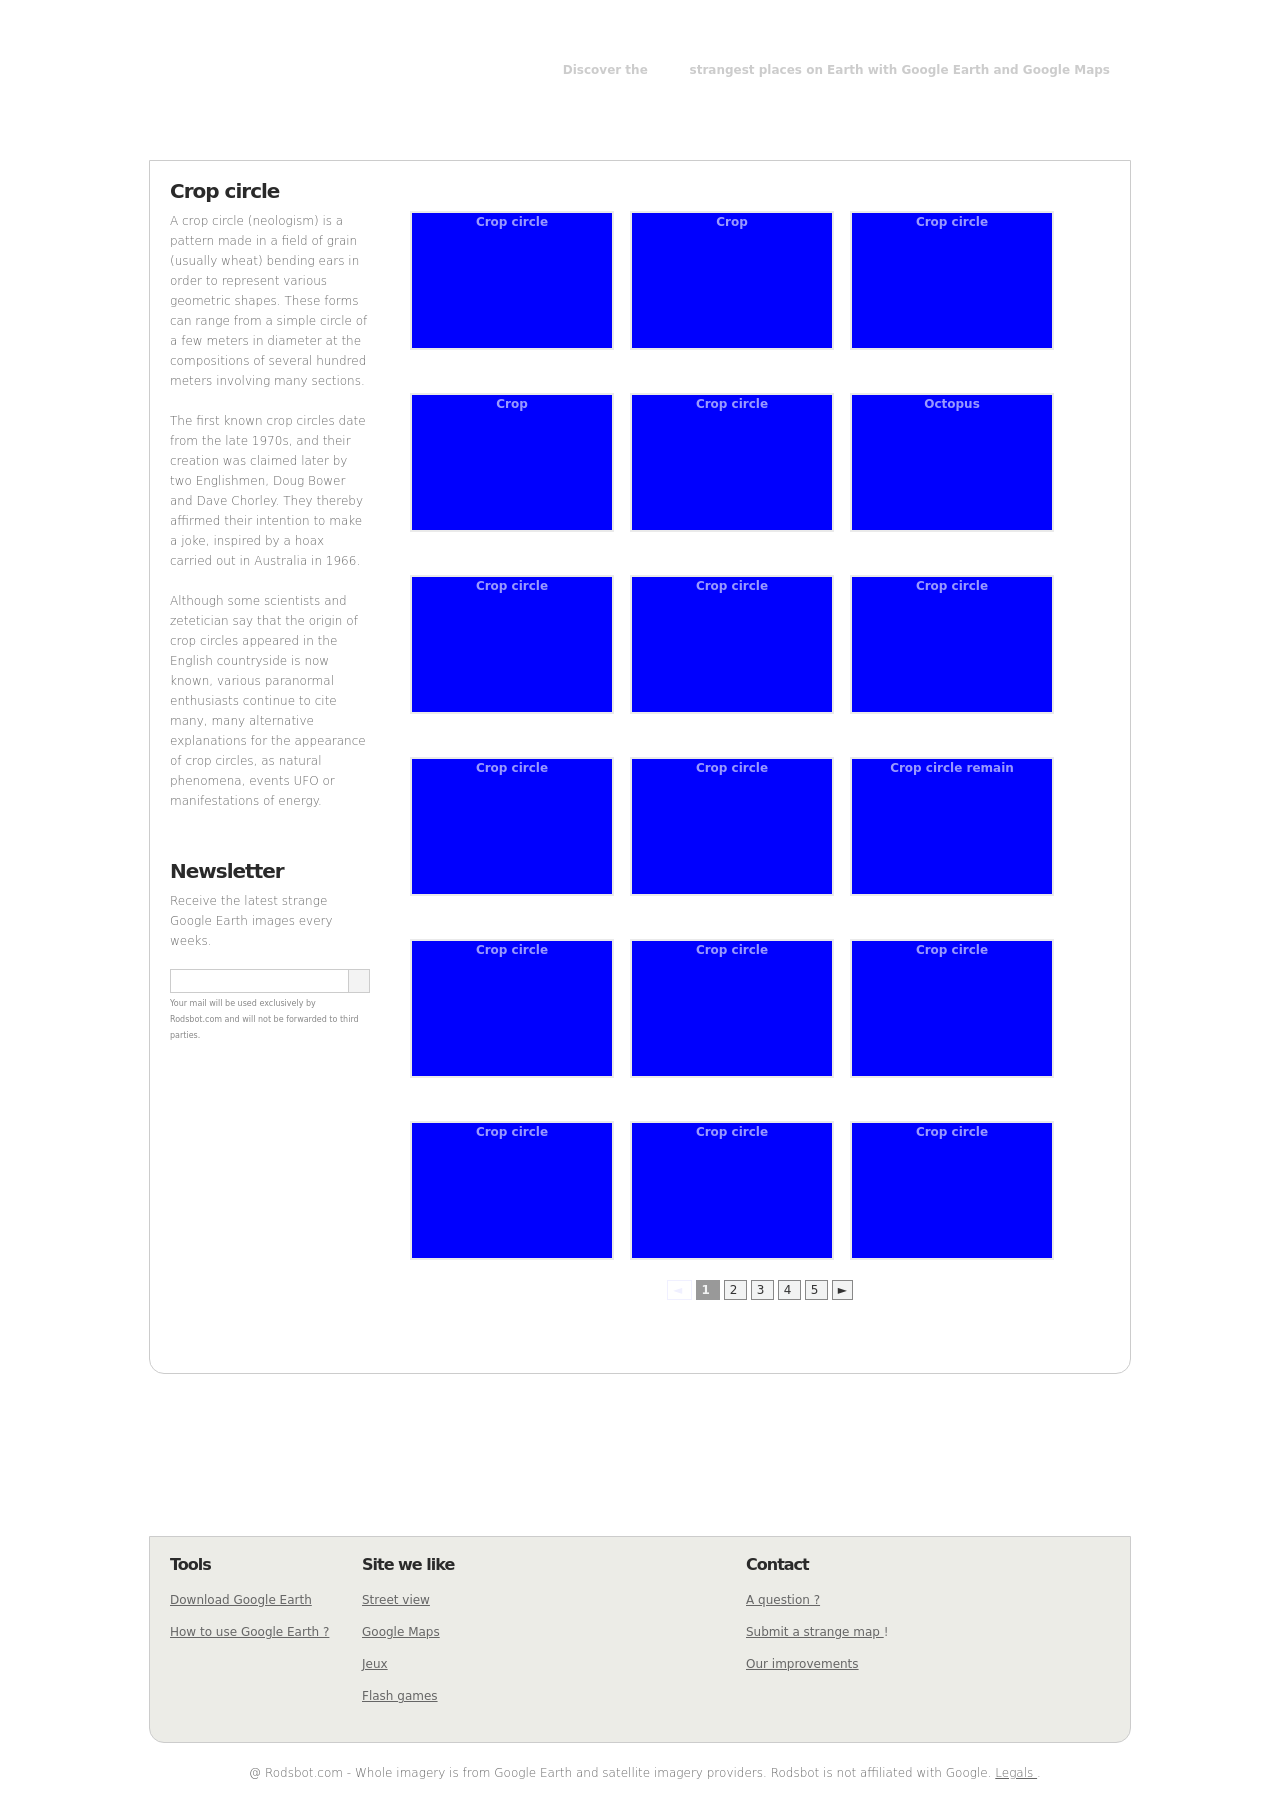How can I subscribe to the newsletter shown in the image for weekly updates on strange Google Earth images? To subscribe to the newsletter as depicted in the image, you would typically find a form on the webpage where you can enter your email address. Look for a section with a form field and possibly a subscription button labeled 'Subscribe' or similar. Enter your email address in the provided field and submit it. This action should register you for weekly updates on strange Google Earth images, as per the site's database. 